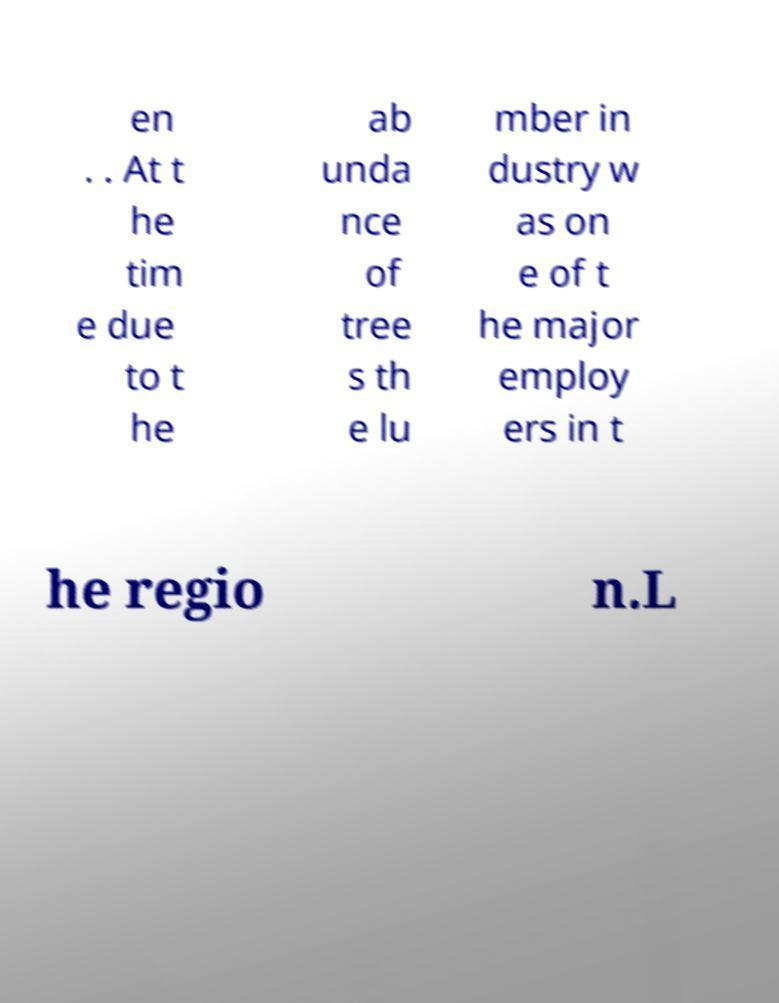What messages or text are displayed in this image? I need them in a readable, typed format. en . . At t he tim e due to t he ab unda nce of tree s th e lu mber in dustry w as on e of t he major employ ers in t he regio n.L 